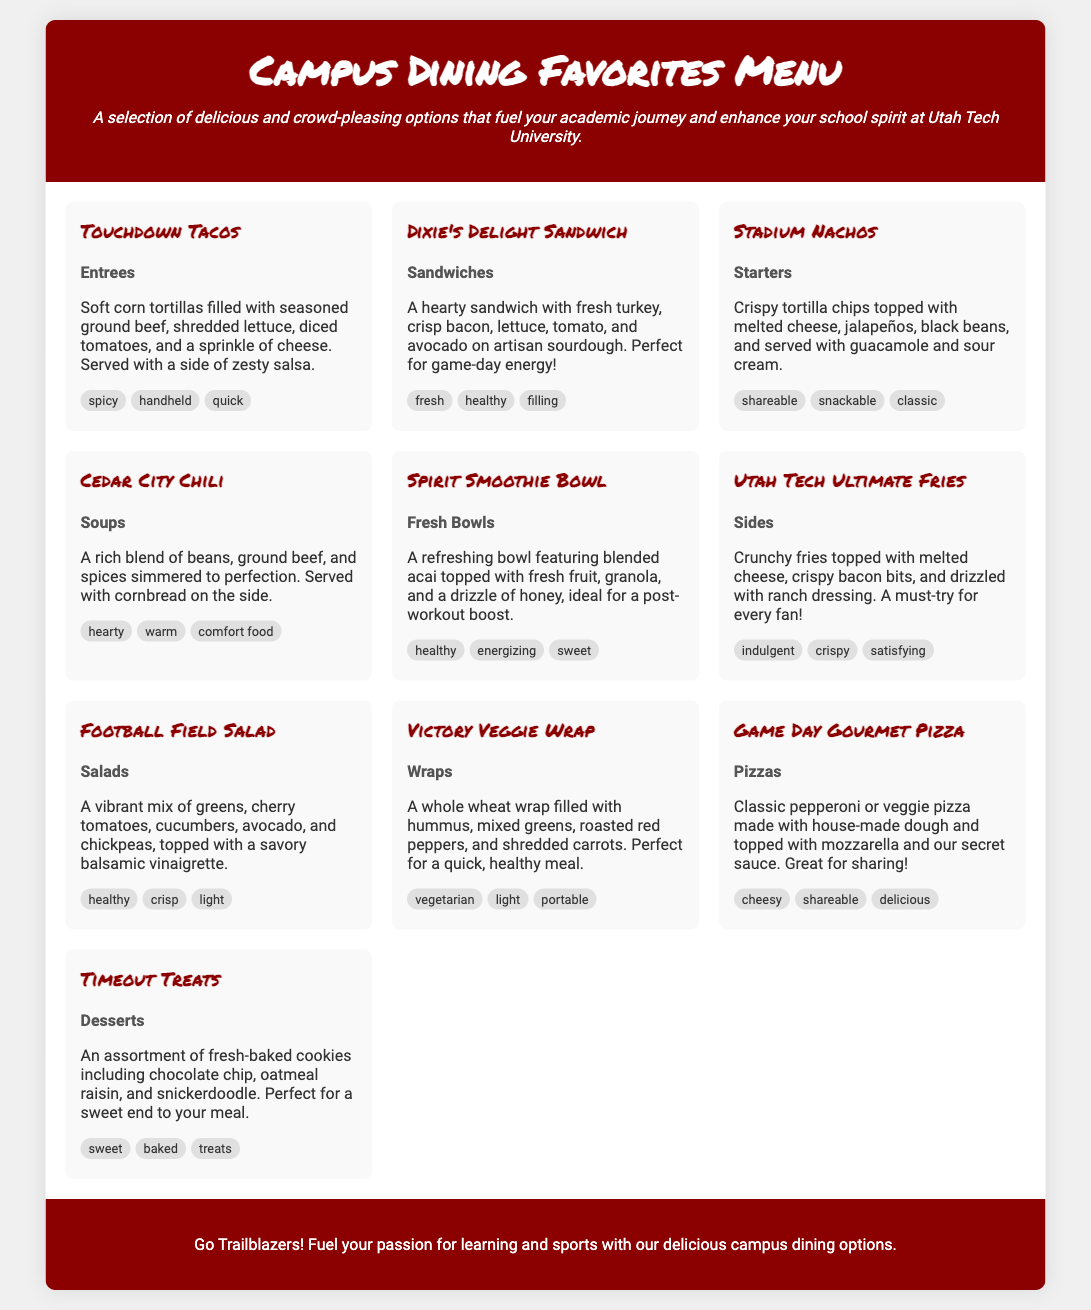What is the first item on the menu? The first item listed in the menu is "Touchdown Tacos."
Answer: Touchdown Tacos How many categories of food are in the menu? The menu features ten distinct food items categorized into entrees, sandwiches, starters, soups, fresh bowls, sides, salads, wraps, pizzas, and desserts.
Answer: 10 What is the primary ingredient in the Victory Veggie Wrap? The primary ingredient in the Victory Veggie Wrap is hummus.
Answer: Hummus Which menu item is described as "perfect for game-day energy"? The menu item described as "perfect for game-day energy" is "Dixie's Delight Sandwich."
Answer: Dixie's Delight Sandwich What type of dish are Stadium Nachos categorized as? Stadium Nachos are categorized as starters.
Answer: Starters Which item is a dessert? The item categorized as a dessert is "Timeout Treats."
Answer: Timeout Treats What is the tag associated with the Spirit Smoothie Bowl? The tags associated with the Spirit Smoothie Bowl include healthy, energizing, and sweet.
Answer: Healthy How is the Game Day Gourmet Pizza described? The Game Day Gourmet Pizza is described as classic pepperoni or veggie pizza made with house-made dough and topped with mozzarella and our secret sauce.
Answer: Classic pepperoni or veggie pizza What is served with Cedar City Chili? Cedar City Chili is served with cornbread on the side.
Answer: Cornbread What is the background color of the footer? The background color of the footer is #8B0000.
Answer: #8B0000 